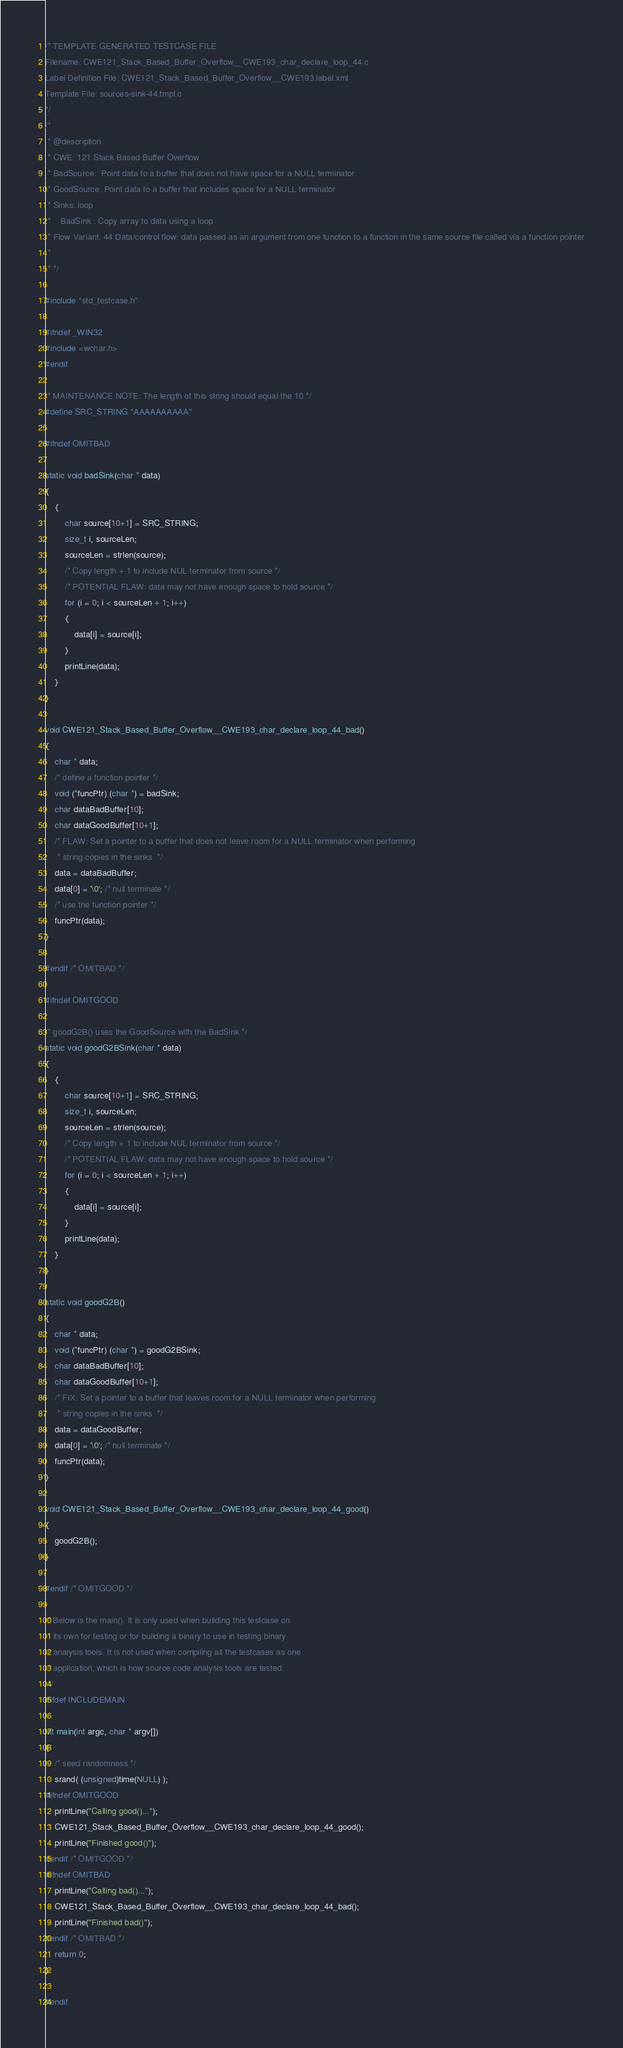<code> <loc_0><loc_0><loc_500><loc_500><_C_>/* TEMPLATE GENERATED TESTCASE FILE
Filename: CWE121_Stack_Based_Buffer_Overflow__CWE193_char_declare_loop_44.c
Label Definition File: CWE121_Stack_Based_Buffer_Overflow__CWE193.label.xml
Template File: sources-sink-44.tmpl.c
*/
/*
 * @description
 * CWE: 121 Stack Based Buffer Overflow
 * BadSource:  Point data to a buffer that does not have space for a NULL terminator
 * GoodSource: Point data to a buffer that includes space for a NULL terminator
 * Sinks: loop
 *    BadSink : Copy array to data using a loop
 * Flow Variant: 44 Data/control flow: data passed as an argument from one function to a function in the same source file called via a function pointer
 *
 * */

#include "std_testcase.h"

#ifndef _WIN32
#include <wchar.h>
#endif

/* MAINTENANCE NOTE: The length of this string should equal the 10 */
#define SRC_STRING "AAAAAAAAAA"

#ifndef OMITBAD

static void badSink(char * data)
{
    {
        char source[10+1] = SRC_STRING;
        size_t i, sourceLen;
        sourceLen = strlen(source);
        /* Copy length + 1 to include NUL terminator from source */
        /* POTENTIAL FLAW: data may not have enough space to hold source */
        for (i = 0; i < sourceLen + 1; i++)
        {
            data[i] = source[i];
        }
        printLine(data);
    }
}

void CWE121_Stack_Based_Buffer_Overflow__CWE193_char_declare_loop_44_bad()
{
    char * data;
    /* define a function pointer */
    void (*funcPtr) (char *) = badSink;
    char dataBadBuffer[10];
    char dataGoodBuffer[10+1];
    /* FLAW: Set a pointer to a buffer that does not leave room for a NULL terminator when performing
     * string copies in the sinks  */
    data = dataBadBuffer;
    data[0] = '\0'; /* null terminate */
    /* use the function pointer */
    funcPtr(data);
}

#endif /* OMITBAD */

#ifndef OMITGOOD

/* goodG2B() uses the GoodSource with the BadSink */
static void goodG2BSink(char * data)
{
    {
        char source[10+1] = SRC_STRING;
        size_t i, sourceLen;
        sourceLen = strlen(source);
        /* Copy length + 1 to include NUL terminator from source */
        /* POTENTIAL FLAW: data may not have enough space to hold source */
        for (i = 0; i < sourceLen + 1; i++)
        {
            data[i] = source[i];
        }
        printLine(data);
    }
}

static void goodG2B()
{
    char * data;
    void (*funcPtr) (char *) = goodG2BSink;
    char dataBadBuffer[10];
    char dataGoodBuffer[10+1];
    /* FIX: Set a pointer to a buffer that leaves room for a NULL terminator when performing
     * string copies in the sinks  */
    data = dataGoodBuffer;
    data[0] = '\0'; /* null terminate */
    funcPtr(data);
}

void CWE121_Stack_Based_Buffer_Overflow__CWE193_char_declare_loop_44_good()
{
    goodG2B();
}

#endif /* OMITGOOD */

/* Below is the main(). It is only used when building this testcase on
 * its own for testing or for building a binary to use in testing binary
 * analysis tools. It is not used when compiling all the testcases as one
 * application, which is how source code analysis tools are tested.
 */
#ifdef INCLUDEMAIN

int main(int argc, char * argv[])
{
    /* seed randomness */
    srand( (unsigned)time(NULL) );
#ifndef OMITGOOD
    printLine("Calling good()...");
    CWE121_Stack_Based_Buffer_Overflow__CWE193_char_declare_loop_44_good();
    printLine("Finished good()");
#endif /* OMITGOOD */
#ifndef OMITBAD
    printLine("Calling bad()...");
    CWE121_Stack_Based_Buffer_Overflow__CWE193_char_declare_loop_44_bad();
    printLine("Finished bad()");
#endif /* OMITBAD */
    return 0;
}

#endif
</code> 